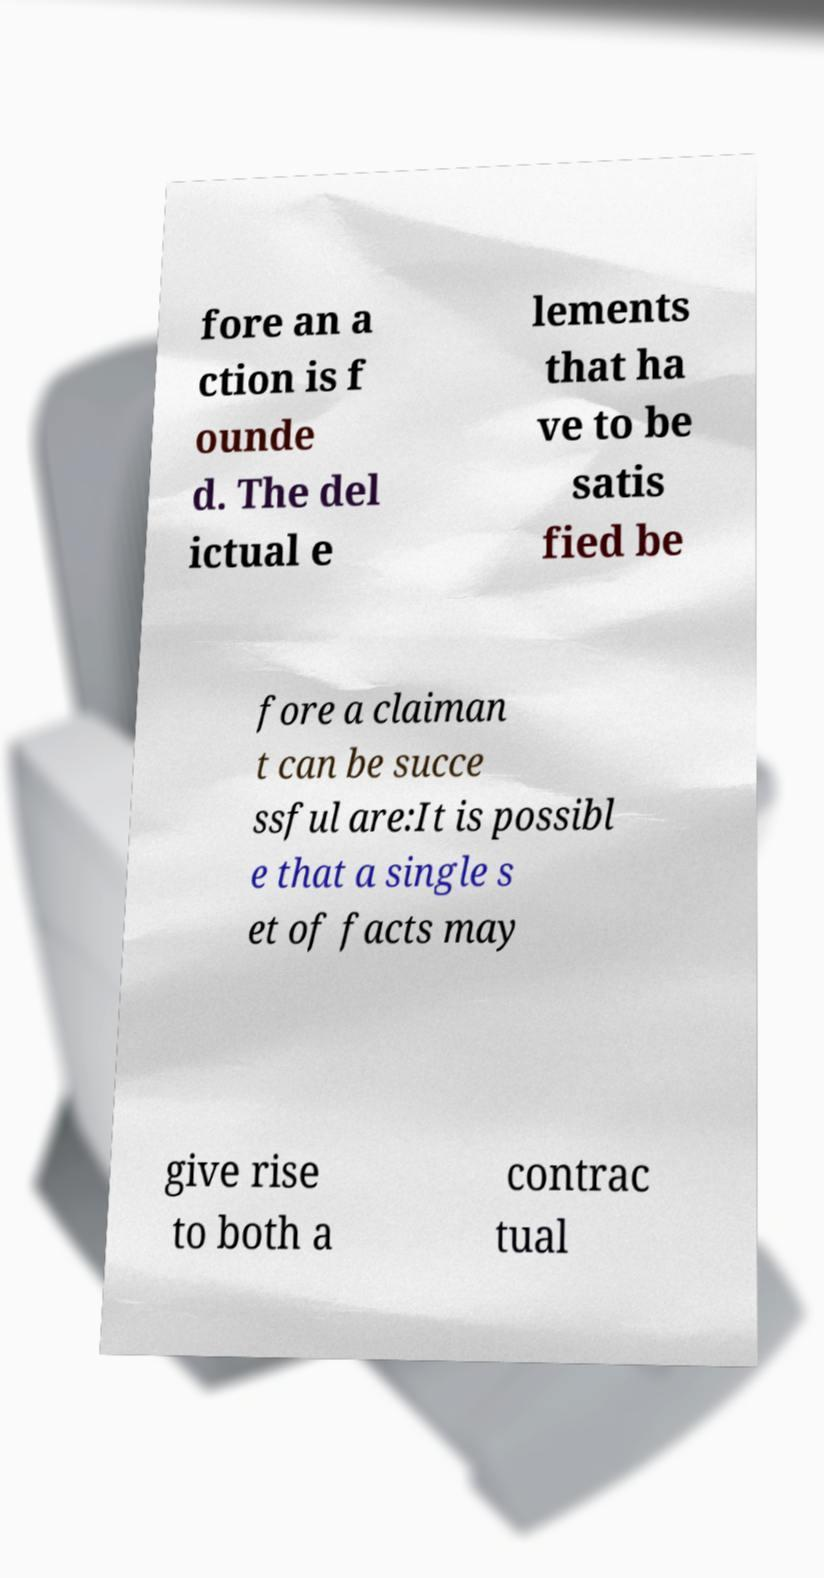There's text embedded in this image that I need extracted. Can you transcribe it verbatim? fore an a ction is f ounde d. The del ictual e lements that ha ve to be satis fied be fore a claiman t can be succe ssful are:It is possibl e that a single s et of facts may give rise to both a contrac tual 